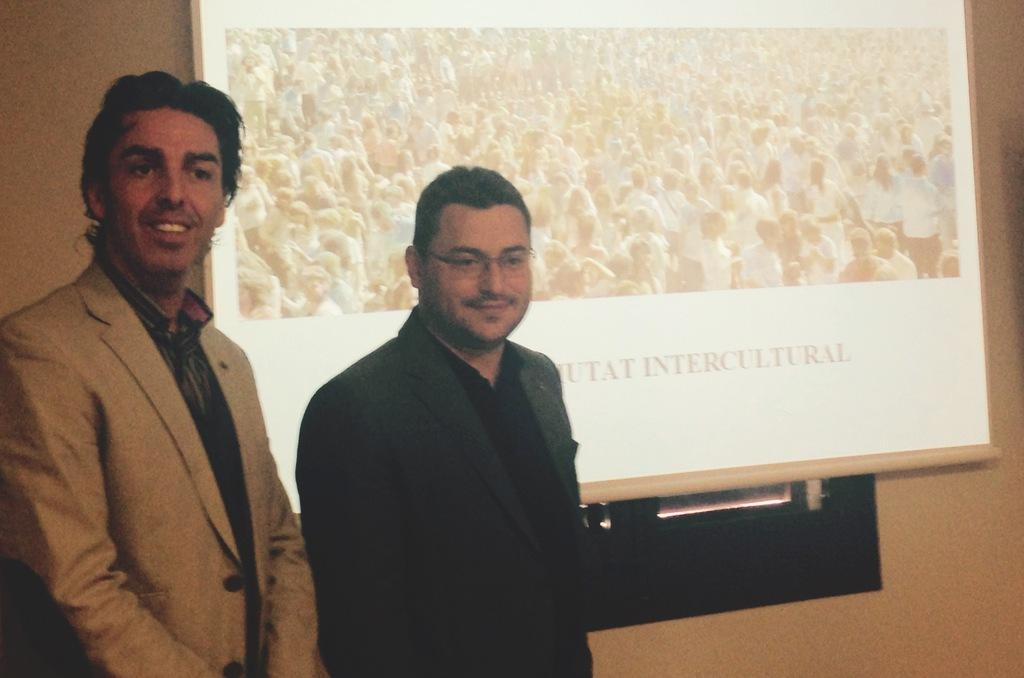How many people are in the image? There are people in the image, but the exact number is not specified. What are the people wearing in the image? The people are wearing coats in the image. What position are the people in? The people are standing in the image. Can you describe any specific accessory one of the people is wearing? One person is wearing glasses in the image. What can be seen on the wall in the background? There is a screen on the wall in the background. What type of produce is being pointed at by the person in the image? There is no produce present in the image, and no one is pointing at anything. 